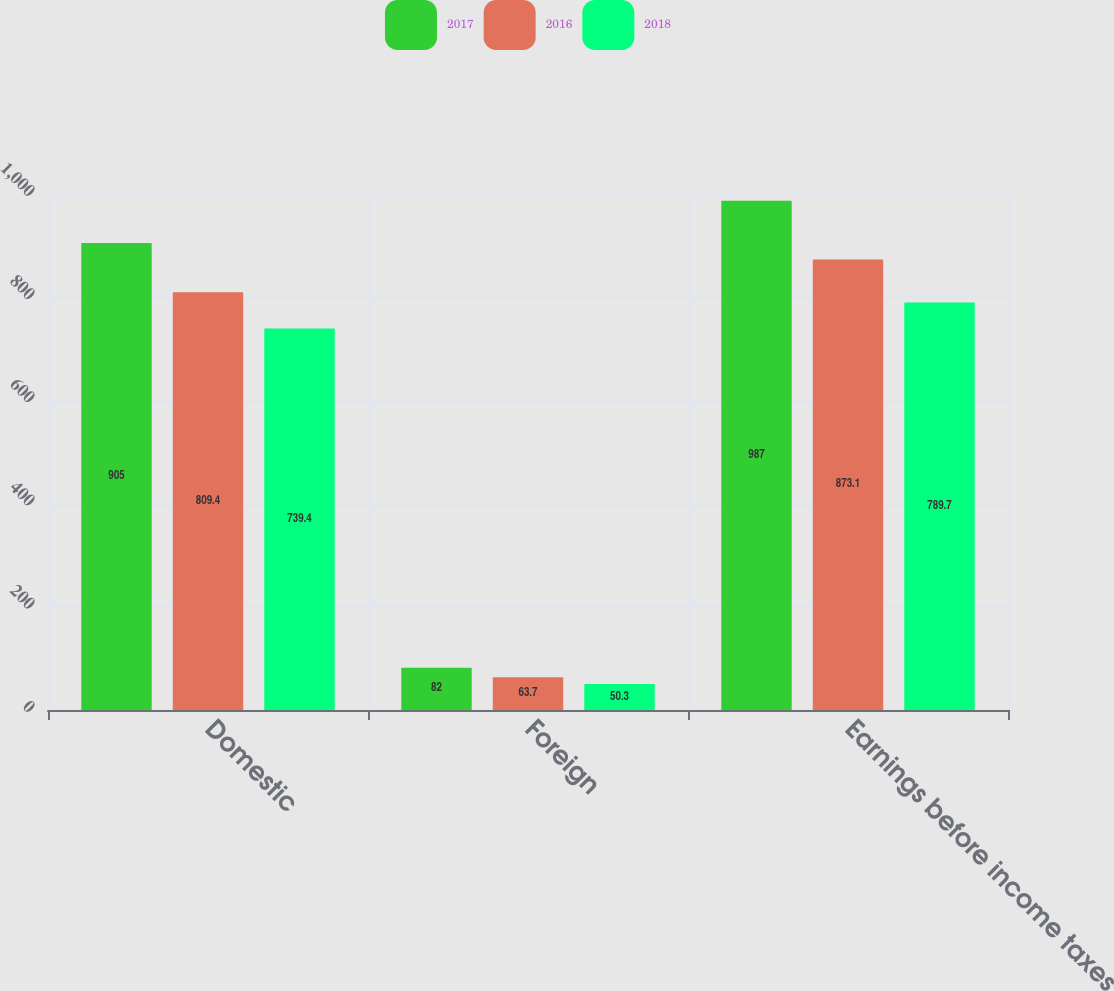Convert chart. <chart><loc_0><loc_0><loc_500><loc_500><stacked_bar_chart><ecel><fcel>Domestic<fcel>Foreign<fcel>Earnings before income taxes<nl><fcel>2017<fcel>905<fcel>82<fcel>987<nl><fcel>2016<fcel>809.4<fcel>63.7<fcel>873.1<nl><fcel>2018<fcel>739.4<fcel>50.3<fcel>789.7<nl></chart> 